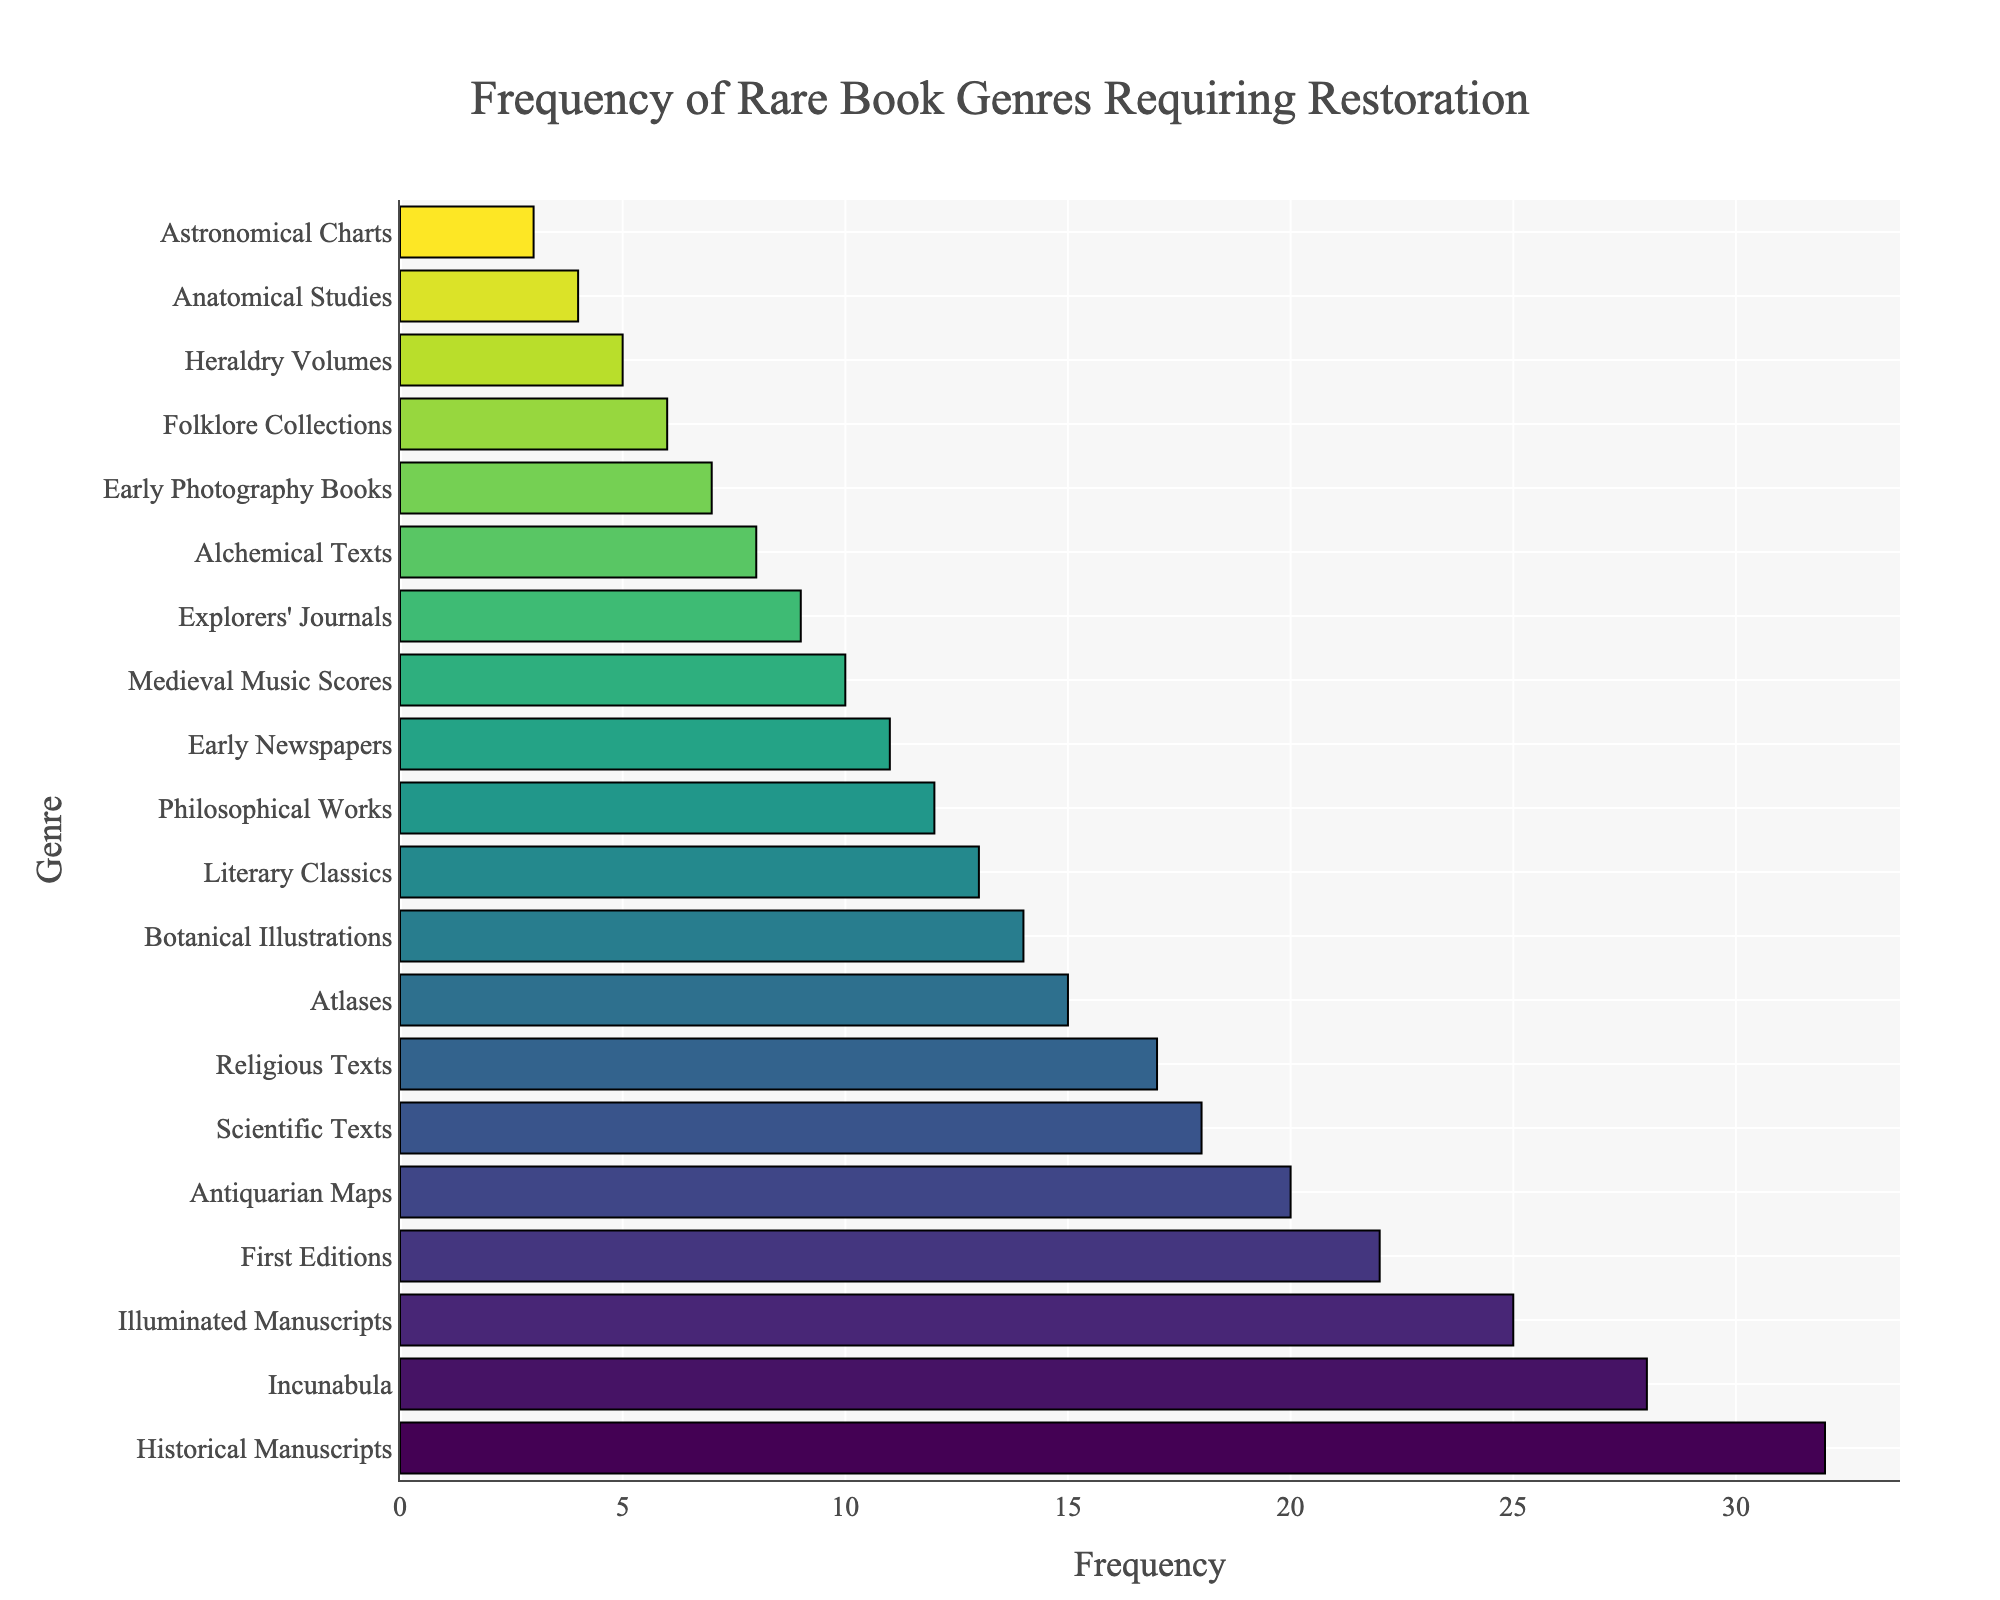Which genre requires the most restoration services? Identify the bar with the longest length representing the genre with the highest frequency.
Answer: Historical Manuscripts Which genres have a frequency greater than 20? Look for bars that extend beyond the value of 20 on the x-axis.
Answer: Historical Manuscripts, Incunabula, Illuminated Manuscripts, First Editions What is the difference in frequency between Historical Manuscripts and Early Photography Books? Subtract the frequency of Early Photography Books from that of Historical Manuscripts (32 - 7).
Answer: 25 How much more frequent are Illuminated Manuscripts compared to Botanical Illustrations? Subtract the frequency of Botanical Illustrations from Illuminated Manuscripts (25 - 14).
Answer: 11 Which two genres have the closest frequencies? Compare the lengths of all adjacent bars in the sorted bar chart and find the smallest difference.
Answer: Religious Texts and Atlases If you combine the frequency of Early Newspapers and Medieval Music Scores, what is the total? Add the frequencies of Early Newspapers and Medieval Music Scores (11 + 10).
Answer: 21 Is the frequency of Explorers' Journals more or less than half of the frequency of Historical Manuscripts? Divide the frequency of Historical Manuscripts by 2 (32 / 2 = 16) and compare with Explorers' Journals' frequency (9).
Answer: Less Which genres are represented with colors transitioning from green to yellow, and what might this indicate about their frequencies? Observe the color scheme where the green to yellow transition indicates mid-range frequencies in the bar's color gradient.
Answer: Religious Texts, Atlases, Botanical Illustrations, Literary Classics What is the average frequency of the top three genres requiring restoration services? Add the frequencies of the top three genres and divide by 3 ((32 + 28 + 25) / 3).
Answer: 28.33 How many genres have a frequency less than 10? Count the number of bars that have a length corresponding to frequencies less than 10.
Answer: 5 